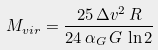Convert formula to latex. <formula><loc_0><loc_0><loc_500><loc_500>M _ { v i r } = \frac { 2 5 \, \Delta v ^ { 2 } \, R } { 2 4 \, \alpha _ { G } \, G \, \ln 2 }</formula> 